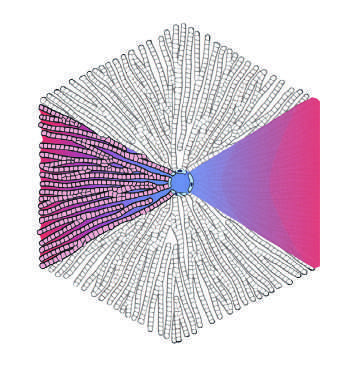s a large amount of black pigment the farthest?
Answer the question using a single word or phrase. No 